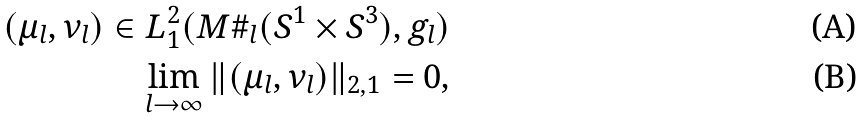Convert formula to latex. <formula><loc_0><loc_0><loc_500><loc_500>( \mu _ { l } , \nu _ { l } ) \in L ^ { 2 } _ { 1 } ( M \# _ { l } ( S ^ { 1 } \times S ^ { 3 } ) , g _ { l } ) \\ \lim _ { l \to \infty } \| ( \mu _ { l } , \nu _ { l } ) \| _ { 2 , 1 } = 0 ,</formula> 